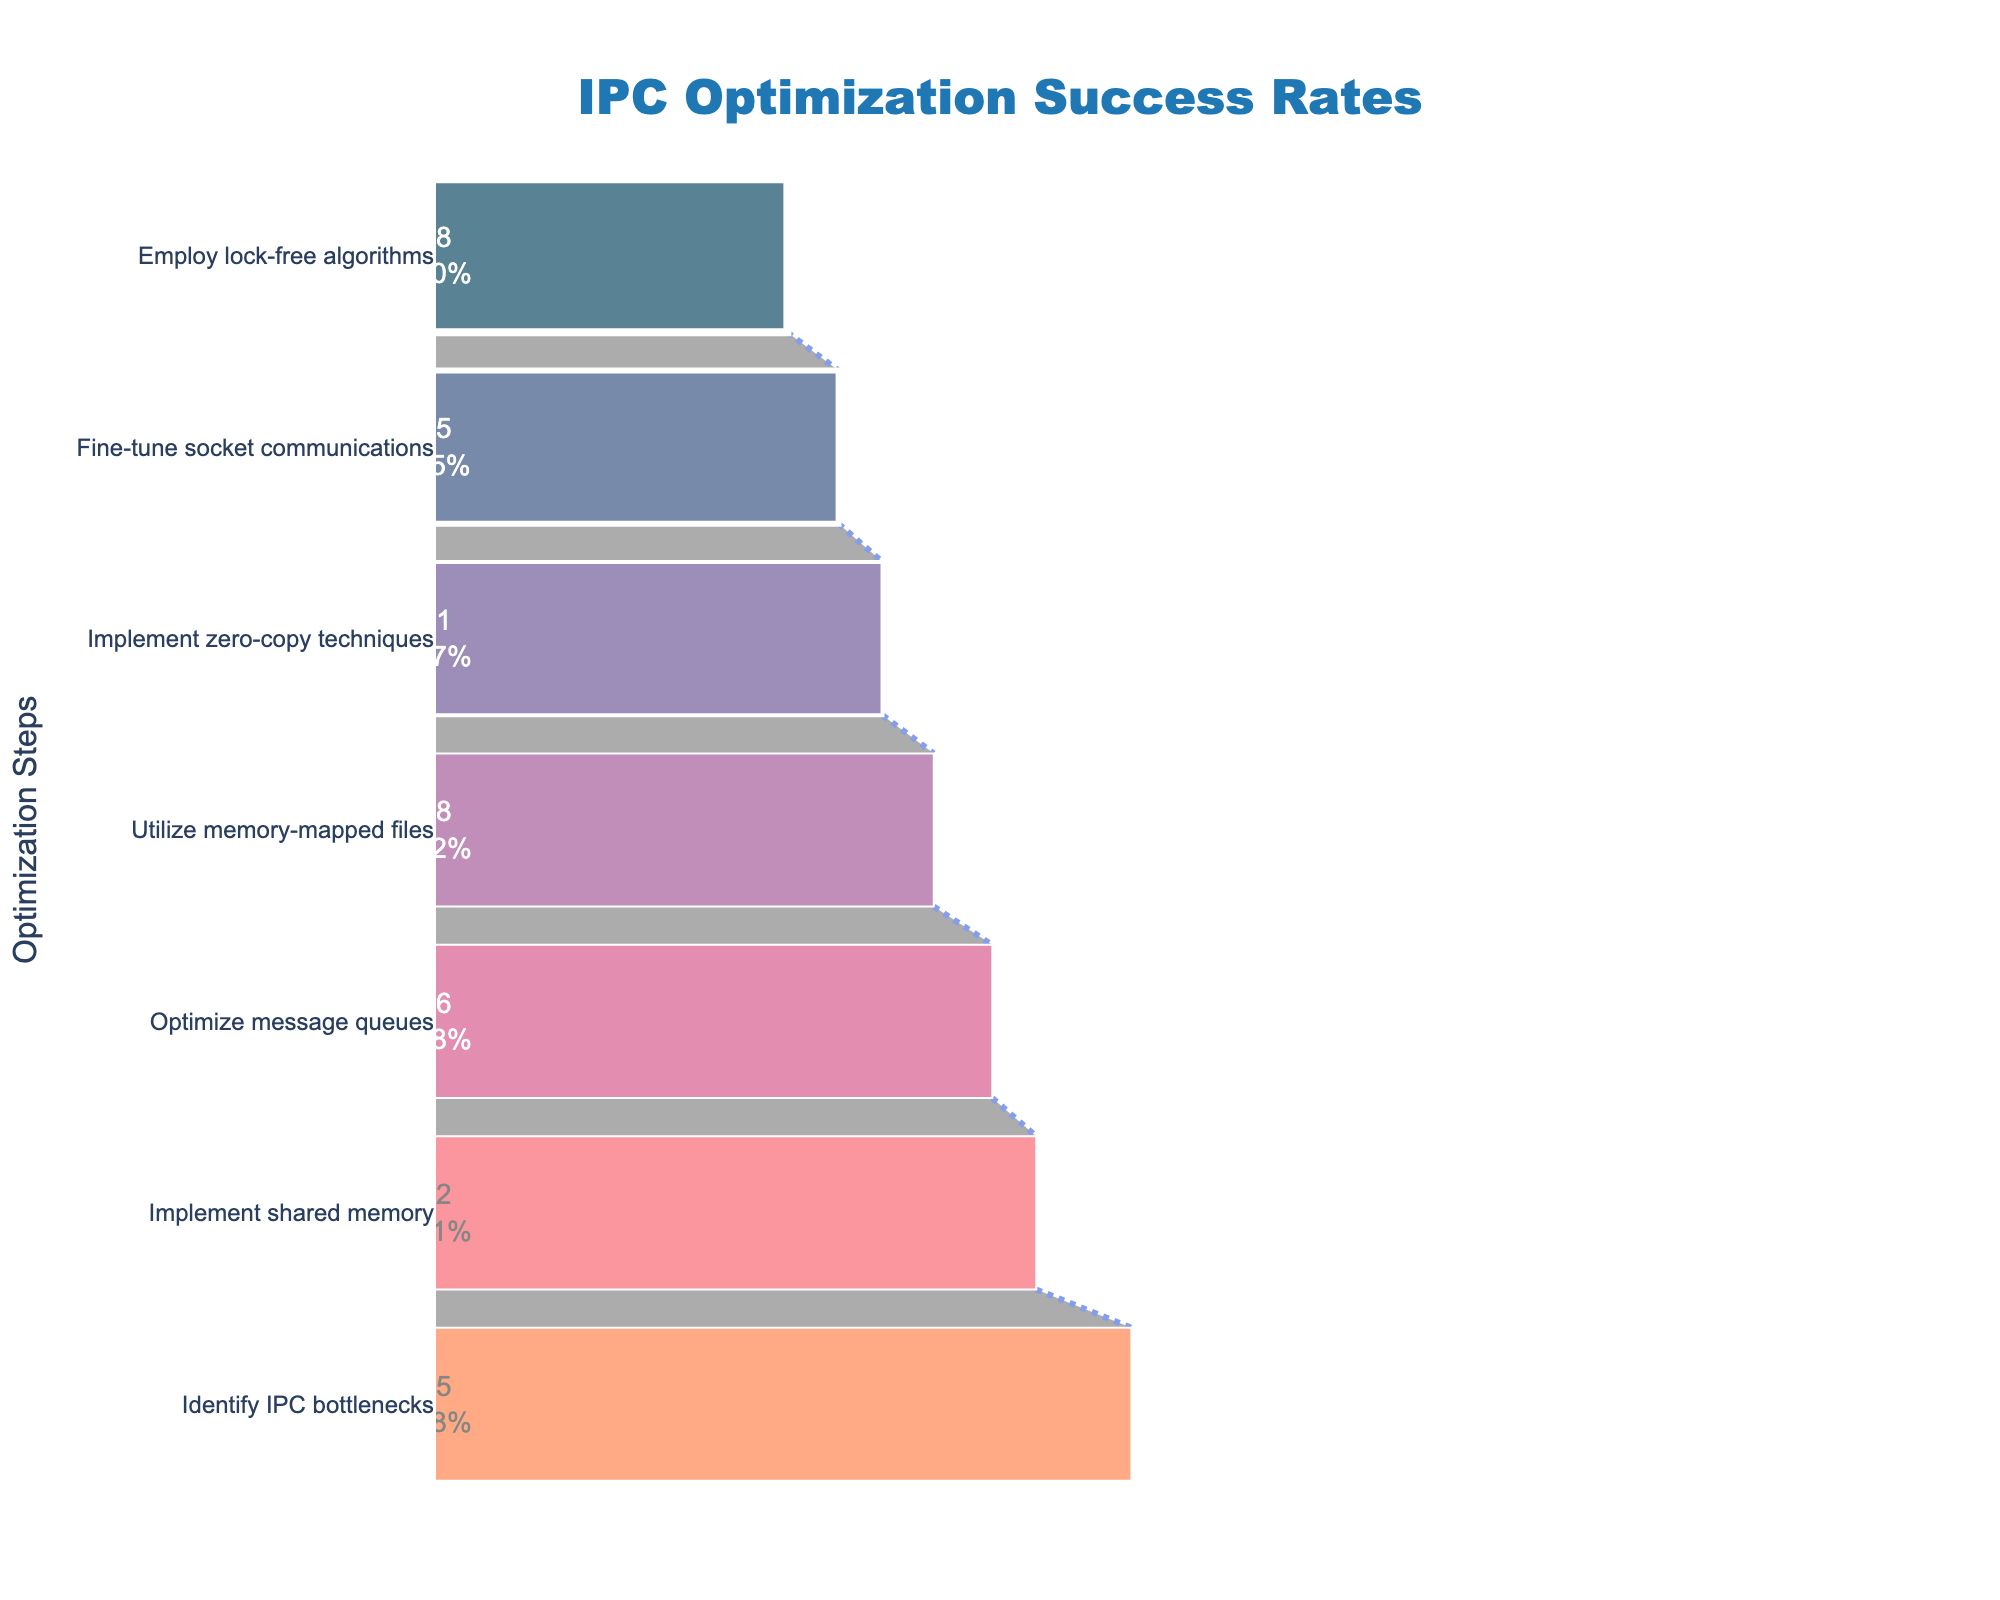What is the title of the funnel chart? The title is located at the top of the chart and usually gives an overview of what the chart represents. In this case, it mentions "IPC Optimization Success Rates".
Answer: IPC Optimization Success Rates Which IPC optimization step has the highest success rate? The highest success rate refers to the largest value on the horizontal axis. By looking at the chart, the step with the highest bar is "Identify IPC bottlenecks" which has a success rate of 95%.
Answer: Identify IPC bottlenecks How many optimization steps are represented in the funnel chart? You can count the number of distinct labels or steps listed along the vertical axis of the funnel chart. There are seven steps listed.
Answer: 7 What is the success rate for implementing zero-copy techniques? Locate the "Implement zero-copy techniques" step along the vertical axis and follow the corresponding bar to its endpoint on the horizontal axis, which is 61%.
Answer: 61% Which optimization step has a lower success rate, "Utilize memory-mapped files" or "Fine-tune socket communications"? Compare the horizontal extents of the bars for both steps. "Fine-tune socket communications" has a success rate of 55% while "Utilize memory-mapped files" has a success rate of 68%, so "Fine-tune socket communications" has a lower success rate.
Answer: Fine-tune socket communications What is the difference in success rates between "Optimize message queues" and "Employ lock-free algorithms"? Subtract the success rate of "Employ lock-free algorithms" (48%) from that of "Optimize message queues" (76%). The difference is 76% - 48% = 28%.
Answer: 28% Which IPC optimization step has a success rate closest to 50%? Closest refers to the difference from 50%. The "Fine-tune socket communications" step has a success rate of 55%, which is the closest to 50% compared to other steps.
Answer: Fine-tune socket communications What is the average success rate of all the optimization steps? Sum all the success rates and divide by the number of steps. The rates are 95, 82, 76, 68, 61, 55, 48. Total is 485. Average is 485 / 7 = 69.29%.
Answer: 69.29% Which optimization step decreased the success rate the most from the previous step? Look for the biggest drop in successive success rates. The largest drop is from "Identify IPC bottlenecks" (95%) to "Implement shared memory" (82%), which is a drop of 95% - 82% = 13%.
Answer: Implement shared memory Is the success rate of "Optimize message queues" greater than the average success rate of all steps? The average success rate is 69.29%. The success rate of "Optimize message queues" is 76%, which is greater than the average.
Answer: Yes 